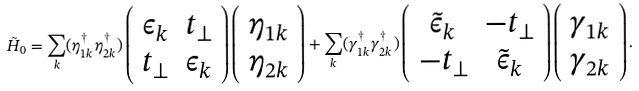<formula> <loc_0><loc_0><loc_500><loc_500>\tilde { H } _ { 0 } = \sum _ { k } ( \eta ^ { \dag } _ { 1 k } \eta ^ { \dag } _ { 2 k } ) \left ( \begin{array} { c c } \epsilon _ { k } & t _ { \perp } \\ t _ { \perp } & \epsilon _ { k } \\ \end{array} \right ) \left ( \begin{array} { c c } \eta _ { 1 k } \\ \eta _ { 2 k } \\ \end{array} \right ) + \sum _ { k } ( \gamma ^ { \dag } _ { 1 k } \gamma ^ { \dag } _ { 2 k } ) \left ( \begin{array} { c c } \tilde { \epsilon } _ { k } & - t _ { \perp } \\ - t _ { \perp } & \tilde { \epsilon } _ { k } \\ \end{array} \right ) \left ( \begin{array} { c c } \gamma _ { 1 k } \\ \gamma _ { 2 k } \\ \end{array} \right ) .</formula> 